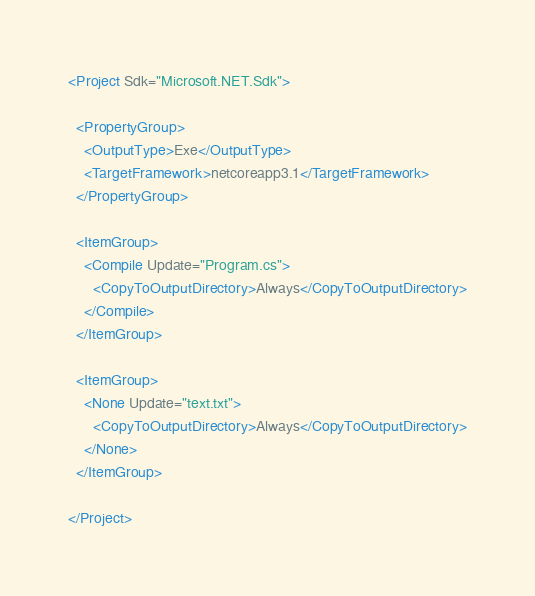Convert code to text. <code><loc_0><loc_0><loc_500><loc_500><_XML_><Project Sdk="Microsoft.NET.Sdk">

  <PropertyGroup>
    <OutputType>Exe</OutputType>
    <TargetFramework>netcoreapp3.1</TargetFramework>
  </PropertyGroup>

  <ItemGroup>
    <Compile Update="Program.cs">
      <CopyToOutputDirectory>Always</CopyToOutputDirectory>
    </Compile>
  </ItemGroup>

  <ItemGroup>
    <None Update="text.txt">
      <CopyToOutputDirectory>Always</CopyToOutputDirectory>
    </None>
  </ItemGroup>

</Project>
</code> 